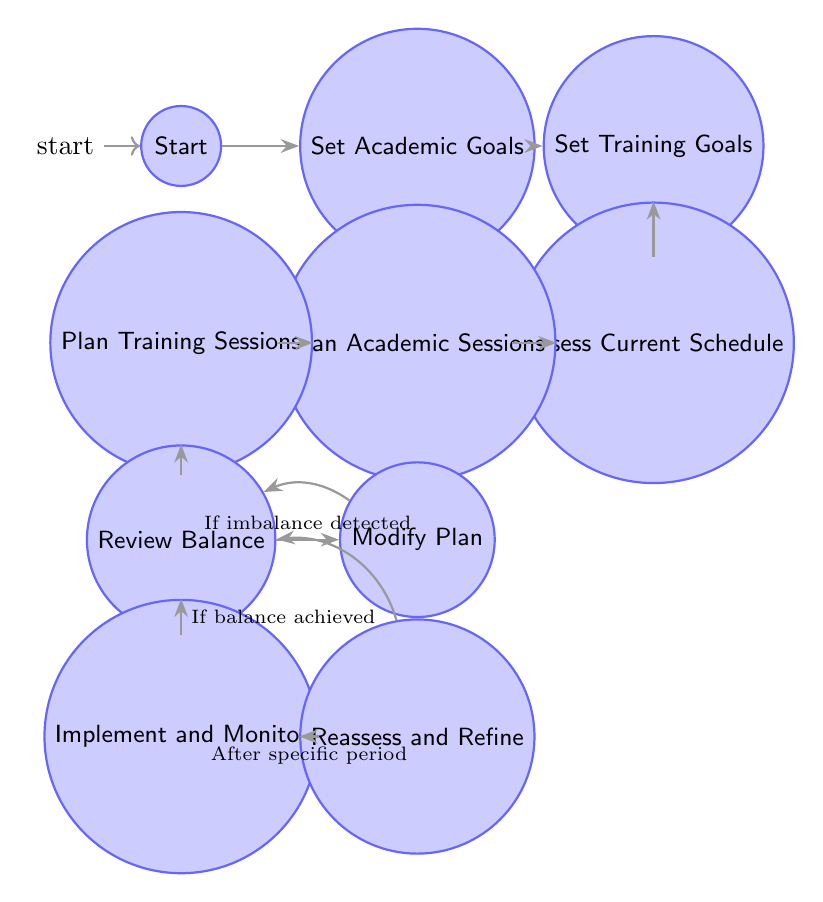What is the starting node in this diagram? The diagram begins at the node labeled "Start", which is the initial point of the process.
Answer: Start How many nodes are in this diagram? Counting the distinct nodes shown, there are a total of 10 nodes represented in the diagram.
Answer: 10 What is the last node in the flow? The last node that follows the sequence in the diagram is "Reassess and Refine", which is the concluding step in the process.
Answer: Reassess and Refine What transition occurs after "Implement and Monitor"? After the "Implement and Monitor" node, the process moves to the "Reassess and Refine" node as the next step in the flow.
Answer: Reassess and Refine Which node comes before "Review Balance"? The node that directly precedes "Review Balance" is "Plan Training Sessions", which is the step taken just before assessing the balance.
Answer: Plan Training Sessions What happens if an imbalance is detected during "Review Balance"? If an imbalance is detected during the "Review Balance" step, the process transitions to the "Modify Plan" node to make adjustments.
Answer: Modify Plan What leads to "Plan Academic Sessions"? The transition to "Plan Academic Sessions" follows after evaluating the current schedule at the "Assess Current Schedule" node.
Answer: Plan Academic Sessions How is balance achieved according to the diagram? When balance is achieved during the "Review Balance" step, the next transition goes to "Implement and Monitor" to execute the plan.
Answer: Implement and Monitor What condition leads to the "Modify Plan" node? The condition to move to the "Modify Plan" node is if an imbalance is detected during the "Review Balance" evaluation process.
Answer: If imbalance detected 